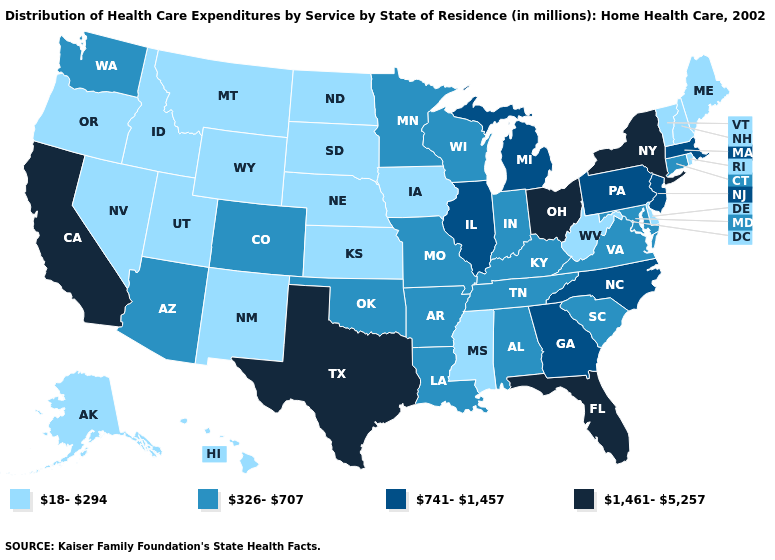Does the first symbol in the legend represent the smallest category?
Be succinct. Yes. Does the map have missing data?
Concise answer only. No. Does Arkansas have the same value as Kentucky?
Quick response, please. Yes. What is the value of Georgia?
Answer briefly. 741-1,457. What is the lowest value in states that border Maryland?
Give a very brief answer. 18-294. Among the states that border Massachusetts , does Rhode Island have the lowest value?
Give a very brief answer. Yes. Which states hav the highest value in the South?
Quick response, please. Florida, Texas. What is the value of Nevada?
Keep it brief. 18-294. What is the value of Maryland?
Give a very brief answer. 326-707. Which states have the lowest value in the MidWest?
Write a very short answer. Iowa, Kansas, Nebraska, North Dakota, South Dakota. Among the states that border Georgia , does North Carolina have the lowest value?
Write a very short answer. No. Does the first symbol in the legend represent the smallest category?
Short answer required. Yes. What is the highest value in states that border New Jersey?
Concise answer only. 1,461-5,257. What is the highest value in the USA?
Keep it brief. 1,461-5,257. Does Louisiana have a higher value than Indiana?
Be succinct. No. 